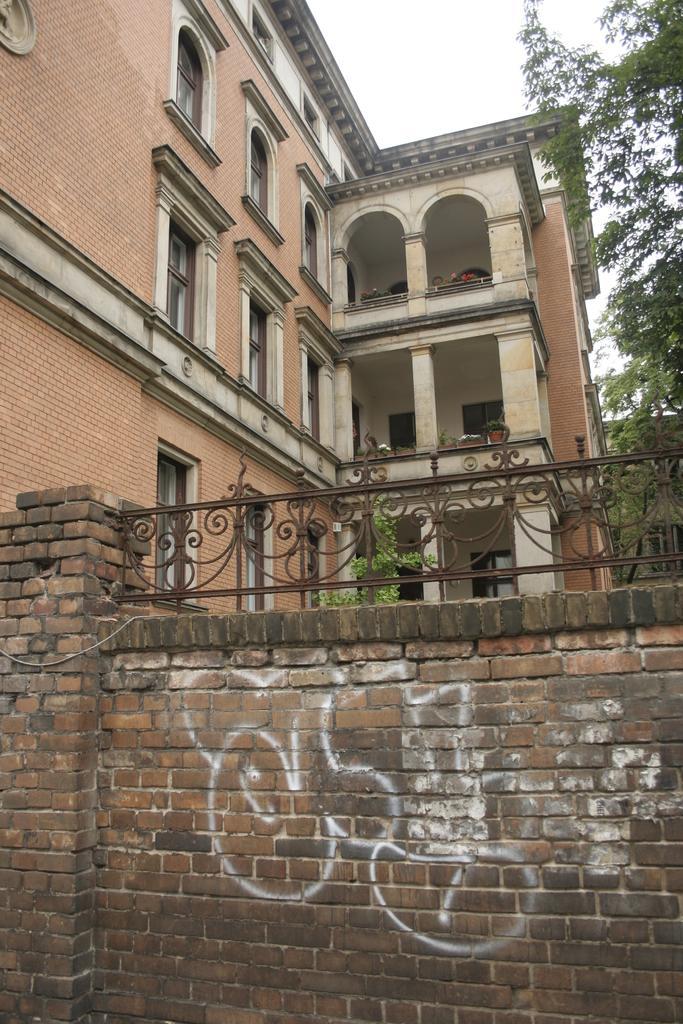How would you summarize this image in a sentence or two? In front of the picture, we see a railing and a wall which is made up of bricks. Behind that, we see a building which is made up of bricks. It has windows and doors. On the right side, we see a tree. At the top of the picture, we see the sky. 